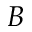<formula> <loc_0><loc_0><loc_500><loc_500>B</formula> 